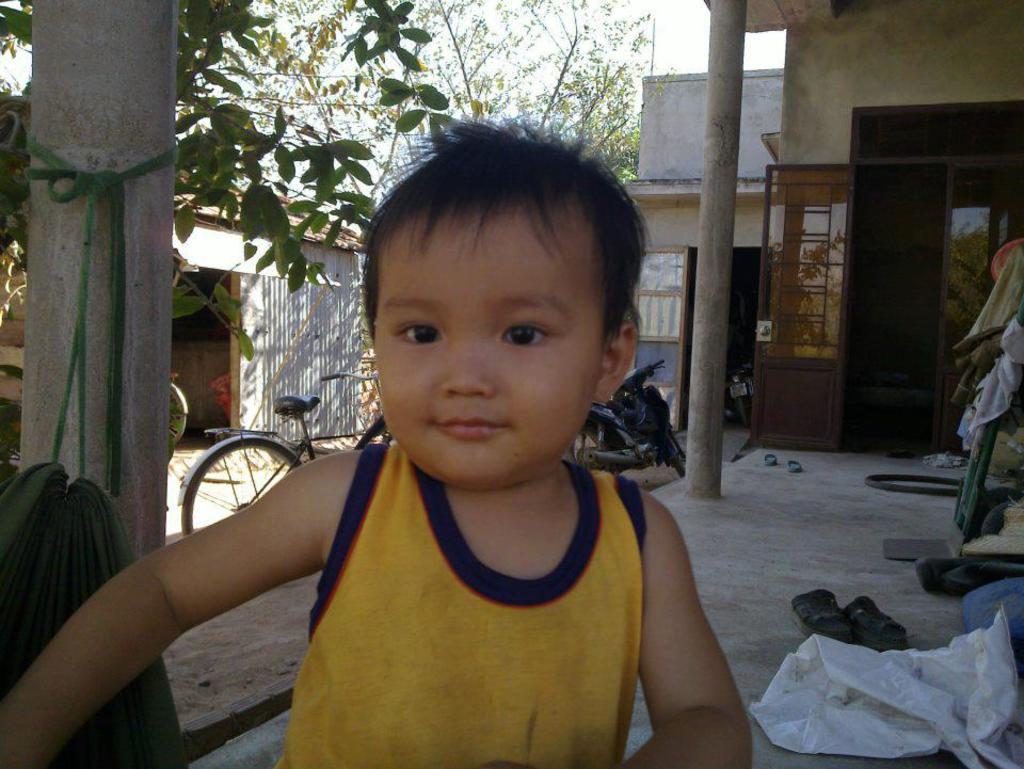In one or two sentences, can you explain what this image depicts? In this image, I can see a boy standing and smiling. I think this is a house. These are the doors and pillars. I can see a bicycle and a motorbike, which are parked. These are the pair of sandals. On the right side of the image, I can see few objects on the floor. These are the trees. This looks like a shed. 